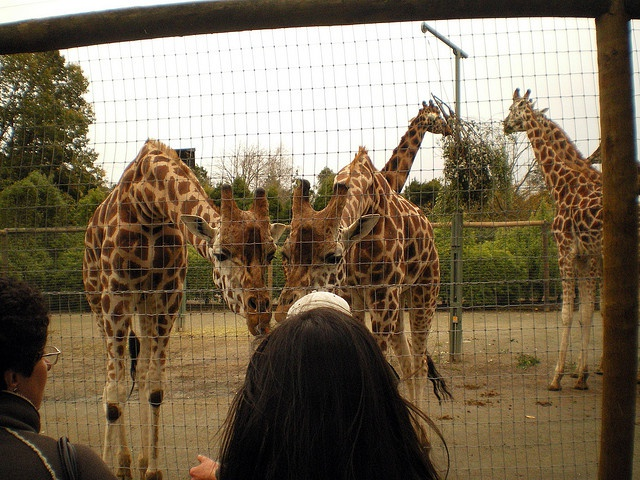Describe the objects in this image and their specific colors. I can see giraffe in ivory, maroon, black, and gray tones, people in ivory, black, maroon, and gray tones, giraffe in ivory, maroon, black, and gray tones, giraffe in ivory, maroon, olive, and gray tones, and people in ivory, black, maroon, and gray tones in this image. 